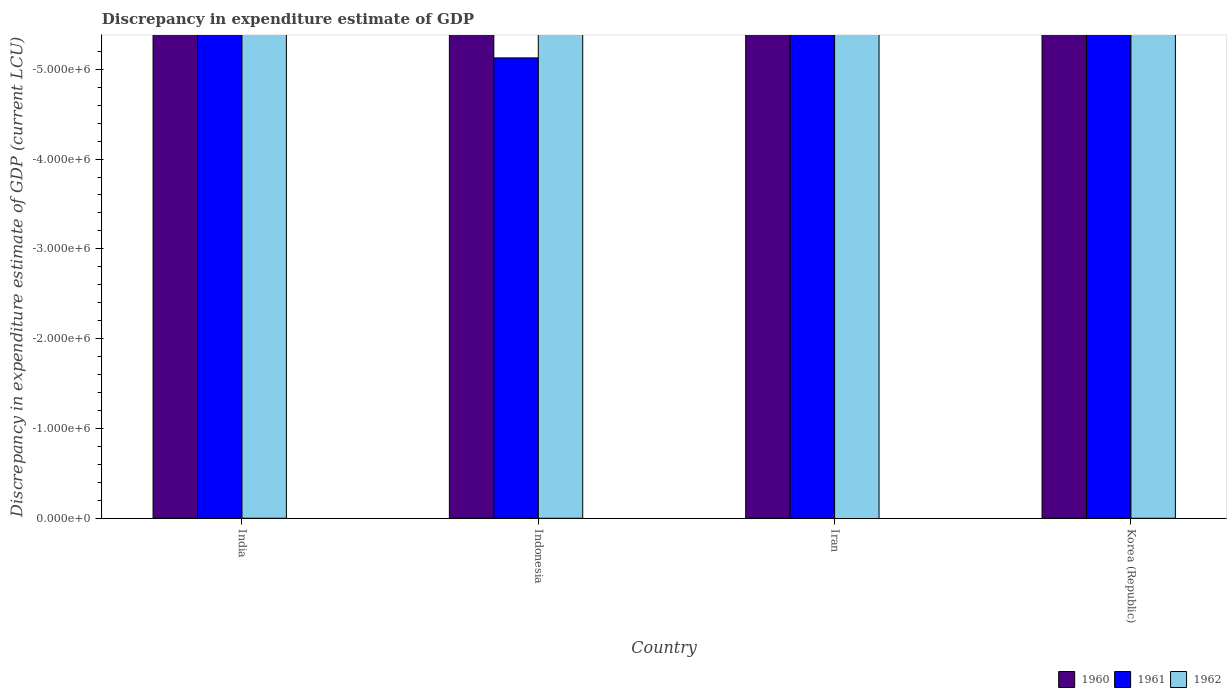How many different coloured bars are there?
Your answer should be compact. 0. How many bars are there on the 2nd tick from the left?
Ensure brevity in your answer.  0. How many bars are there on the 3rd tick from the right?
Make the answer very short. 0. What is the label of the 3rd group of bars from the left?
Give a very brief answer. Iran. What is the difference between the discrepancy in expenditure estimate of GDP in 1961 in India and the discrepancy in expenditure estimate of GDP in 1960 in Indonesia?
Ensure brevity in your answer.  0. In how many countries, is the discrepancy in expenditure estimate of GDP in 1961 greater than the average discrepancy in expenditure estimate of GDP in 1961 taken over all countries?
Give a very brief answer. 0. Is it the case that in every country, the sum of the discrepancy in expenditure estimate of GDP in 1961 and discrepancy in expenditure estimate of GDP in 1962 is greater than the discrepancy in expenditure estimate of GDP in 1960?
Ensure brevity in your answer.  No. Are all the bars in the graph horizontal?
Your answer should be very brief. No. How many countries are there in the graph?
Offer a terse response. 4. Does the graph contain grids?
Your response must be concise. No. How many legend labels are there?
Make the answer very short. 3. How are the legend labels stacked?
Give a very brief answer. Horizontal. What is the title of the graph?
Offer a terse response. Discrepancy in expenditure estimate of GDP. Does "2002" appear as one of the legend labels in the graph?
Your answer should be very brief. No. What is the label or title of the X-axis?
Your answer should be compact. Country. What is the label or title of the Y-axis?
Ensure brevity in your answer.  Discrepancy in expenditure estimate of GDP (current LCU). What is the Discrepancy in expenditure estimate of GDP (current LCU) in 1961 in India?
Offer a very short reply. 0. What is the Discrepancy in expenditure estimate of GDP (current LCU) in 1962 in Indonesia?
Make the answer very short. 0. What is the Discrepancy in expenditure estimate of GDP (current LCU) of 1961 in Iran?
Keep it short and to the point. 0. What is the Discrepancy in expenditure estimate of GDP (current LCU) in 1960 in Korea (Republic)?
Offer a terse response. 0. What is the Discrepancy in expenditure estimate of GDP (current LCU) in 1961 in Korea (Republic)?
Provide a short and direct response. 0. What is the Discrepancy in expenditure estimate of GDP (current LCU) of 1962 in Korea (Republic)?
Your answer should be very brief. 0. What is the total Discrepancy in expenditure estimate of GDP (current LCU) in 1960 in the graph?
Offer a very short reply. 0. What is the total Discrepancy in expenditure estimate of GDP (current LCU) in 1962 in the graph?
Your answer should be very brief. 0. What is the average Discrepancy in expenditure estimate of GDP (current LCU) of 1960 per country?
Give a very brief answer. 0. What is the average Discrepancy in expenditure estimate of GDP (current LCU) in 1961 per country?
Your response must be concise. 0. 